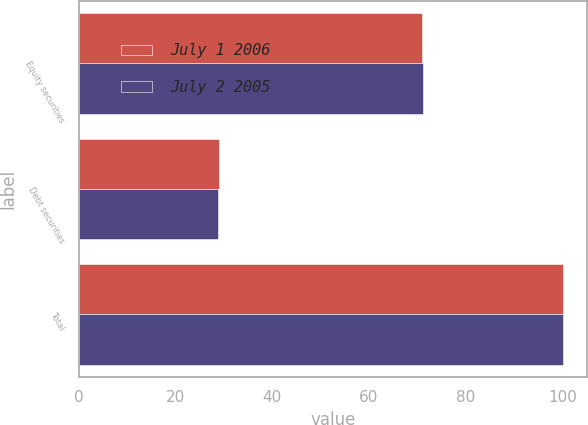Convert chart to OTSL. <chart><loc_0><loc_0><loc_500><loc_500><stacked_bar_chart><ecel><fcel>Equity securities<fcel>Debt securities<fcel>Total<nl><fcel>July 1 2006<fcel>70.9<fcel>29.1<fcel>100<nl><fcel>July 2 2005<fcel>71.2<fcel>28.8<fcel>100<nl></chart> 